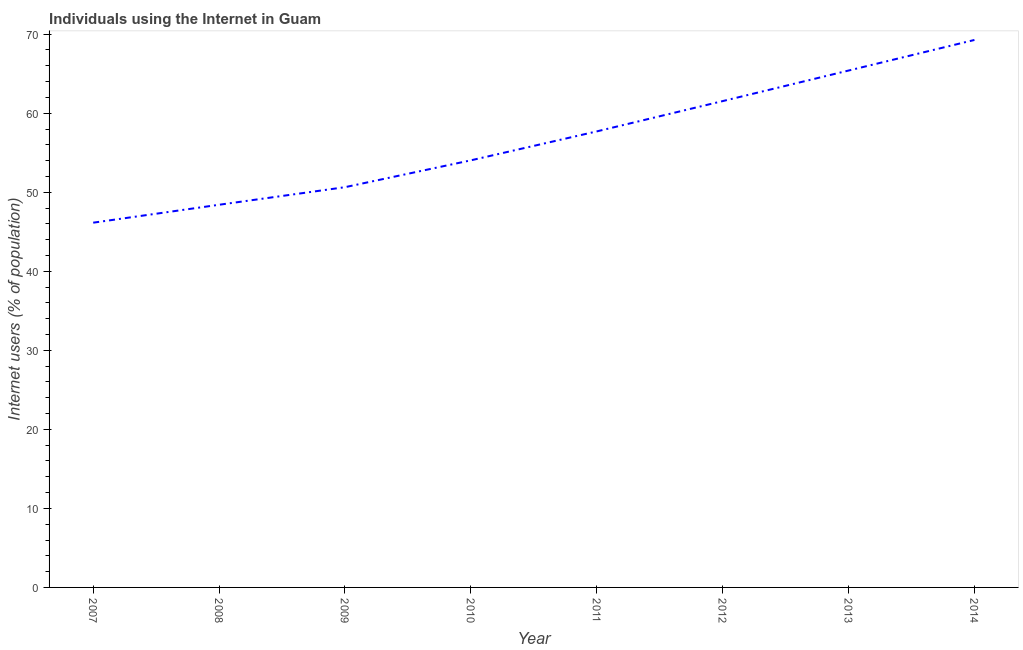What is the number of internet users in 2008?
Offer a very short reply. 48.42. Across all years, what is the maximum number of internet users?
Your response must be concise. 69.27. Across all years, what is the minimum number of internet users?
Keep it short and to the point. 46.15. In which year was the number of internet users maximum?
Offer a very short reply. 2014. In which year was the number of internet users minimum?
Your answer should be compact. 2007. What is the sum of the number of internet users?
Give a very brief answer. 453.16. What is the difference between the number of internet users in 2012 and 2013?
Offer a very short reply. -3.87. What is the average number of internet users per year?
Offer a terse response. 56.64. What is the median number of internet users?
Keep it short and to the point. 55.87. In how many years, is the number of internet users greater than 36 %?
Offer a very short reply. 8. Do a majority of the years between 2013 and 2011 (inclusive) have number of internet users greater than 32 %?
Your answer should be compact. No. What is the ratio of the number of internet users in 2011 to that in 2013?
Offer a terse response. 0.88. What is the difference between the highest and the second highest number of internet users?
Offer a very short reply. 3.87. Is the sum of the number of internet users in 2009 and 2014 greater than the maximum number of internet users across all years?
Your answer should be very brief. Yes. What is the difference between the highest and the lowest number of internet users?
Ensure brevity in your answer.  23.12. How many lines are there?
Keep it short and to the point. 1. What is the difference between two consecutive major ticks on the Y-axis?
Provide a short and direct response. 10. Are the values on the major ticks of Y-axis written in scientific E-notation?
Your answer should be very brief. No. Does the graph contain any zero values?
Provide a short and direct response. No. Does the graph contain grids?
Make the answer very short. No. What is the title of the graph?
Make the answer very short. Individuals using the Internet in Guam. What is the label or title of the X-axis?
Offer a terse response. Year. What is the label or title of the Y-axis?
Offer a very short reply. Internet users (% of population). What is the Internet users (% of population) in 2007?
Your answer should be compact. 46.15. What is the Internet users (% of population) of 2008?
Make the answer very short. 48.42. What is the Internet users (% of population) in 2009?
Provide a succinct answer. 50.64. What is the Internet users (% of population) in 2010?
Your response must be concise. 54.04. What is the Internet users (% of population) in 2011?
Ensure brevity in your answer.  57.7. What is the Internet users (% of population) of 2012?
Offer a terse response. 61.53. What is the Internet users (% of population) of 2013?
Offer a very short reply. 65.4. What is the Internet users (% of population) in 2014?
Provide a short and direct response. 69.27. What is the difference between the Internet users (% of population) in 2007 and 2008?
Provide a short and direct response. -2.27. What is the difference between the Internet users (% of population) in 2007 and 2009?
Ensure brevity in your answer.  -4.49. What is the difference between the Internet users (% of population) in 2007 and 2010?
Your answer should be compact. -7.89. What is the difference between the Internet users (% of population) in 2007 and 2011?
Offer a terse response. -11.55. What is the difference between the Internet users (% of population) in 2007 and 2012?
Your response must be concise. -15.38. What is the difference between the Internet users (% of population) in 2007 and 2013?
Your response must be concise. -19.25. What is the difference between the Internet users (% of population) in 2007 and 2014?
Your answer should be compact. -23.12. What is the difference between the Internet users (% of population) in 2008 and 2009?
Keep it short and to the point. -2.22. What is the difference between the Internet users (% of population) in 2008 and 2010?
Ensure brevity in your answer.  -5.62. What is the difference between the Internet users (% of population) in 2008 and 2011?
Make the answer very short. -9.28. What is the difference between the Internet users (% of population) in 2008 and 2012?
Provide a succinct answer. -13.12. What is the difference between the Internet users (% of population) in 2008 and 2013?
Your answer should be compact. -16.98. What is the difference between the Internet users (% of population) in 2008 and 2014?
Provide a succinct answer. -20.85. What is the difference between the Internet users (% of population) in 2009 and 2010?
Give a very brief answer. -3.4. What is the difference between the Internet users (% of population) in 2009 and 2011?
Your answer should be compact. -7.06. What is the difference between the Internet users (% of population) in 2009 and 2012?
Provide a succinct answer. -10.89. What is the difference between the Internet users (% of population) in 2009 and 2013?
Your response must be concise. -14.76. What is the difference between the Internet users (% of population) in 2009 and 2014?
Offer a terse response. -18.63. What is the difference between the Internet users (% of population) in 2010 and 2011?
Offer a terse response. -3.66. What is the difference between the Internet users (% of population) in 2010 and 2012?
Keep it short and to the point. -7.49. What is the difference between the Internet users (% of population) in 2010 and 2013?
Provide a succinct answer. -11.36. What is the difference between the Internet users (% of population) in 2010 and 2014?
Make the answer very short. -15.23. What is the difference between the Internet users (% of population) in 2011 and 2012?
Offer a very short reply. -3.83. What is the difference between the Internet users (% of population) in 2011 and 2014?
Give a very brief answer. -11.57. What is the difference between the Internet users (% of population) in 2012 and 2013?
Give a very brief answer. -3.87. What is the difference between the Internet users (% of population) in 2012 and 2014?
Give a very brief answer. -7.74. What is the difference between the Internet users (% of population) in 2013 and 2014?
Make the answer very short. -3.87. What is the ratio of the Internet users (% of population) in 2007 to that in 2008?
Provide a succinct answer. 0.95. What is the ratio of the Internet users (% of population) in 2007 to that in 2009?
Your answer should be very brief. 0.91. What is the ratio of the Internet users (% of population) in 2007 to that in 2010?
Provide a succinct answer. 0.85. What is the ratio of the Internet users (% of population) in 2007 to that in 2012?
Offer a terse response. 0.75. What is the ratio of the Internet users (% of population) in 2007 to that in 2013?
Offer a terse response. 0.71. What is the ratio of the Internet users (% of population) in 2007 to that in 2014?
Your answer should be very brief. 0.67. What is the ratio of the Internet users (% of population) in 2008 to that in 2009?
Your response must be concise. 0.96. What is the ratio of the Internet users (% of population) in 2008 to that in 2010?
Provide a short and direct response. 0.9. What is the ratio of the Internet users (% of population) in 2008 to that in 2011?
Keep it short and to the point. 0.84. What is the ratio of the Internet users (% of population) in 2008 to that in 2012?
Offer a terse response. 0.79. What is the ratio of the Internet users (% of population) in 2008 to that in 2013?
Offer a terse response. 0.74. What is the ratio of the Internet users (% of population) in 2008 to that in 2014?
Keep it short and to the point. 0.7. What is the ratio of the Internet users (% of population) in 2009 to that in 2010?
Offer a terse response. 0.94. What is the ratio of the Internet users (% of population) in 2009 to that in 2011?
Your answer should be very brief. 0.88. What is the ratio of the Internet users (% of population) in 2009 to that in 2012?
Offer a terse response. 0.82. What is the ratio of the Internet users (% of population) in 2009 to that in 2013?
Ensure brevity in your answer.  0.77. What is the ratio of the Internet users (% of population) in 2009 to that in 2014?
Give a very brief answer. 0.73. What is the ratio of the Internet users (% of population) in 2010 to that in 2011?
Provide a succinct answer. 0.94. What is the ratio of the Internet users (% of population) in 2010 to that in 2012?
Make the answer very short. 0.88. What is the ratio of the Internet users (% of population) in 2010 to that in 2013?
Provide a succinct answer. 0.83. What is the ratio of the Internet users (% of population) in 2010 to that in 2014?
Provide a short and direct response. 0.78. What is the ratio of the Internet users (% of population) in 2011 to that in 2012?
Your answer should be compact. 0.94. What is the ratio of the Internet users (% of population) in 2011 to that in 2013?
Provide a succinct answer. 0.88. What is the ratio of the Internet users (% of population) in 2011 to that in 2014?
Keep it short and to the point. 0.83. What is the ratio of the Internet users (% of population) in 2012 to that in 2013?
Your response must be concise. 0.94. What is the ratio of the Internet users (% of population) in 2012 to that in 2014?
Offer a terse response. 0.89. What is the ratio of the Internet users (% of population) in 2013 to that in 2014?
Provide a succinct answer. 0.94. 